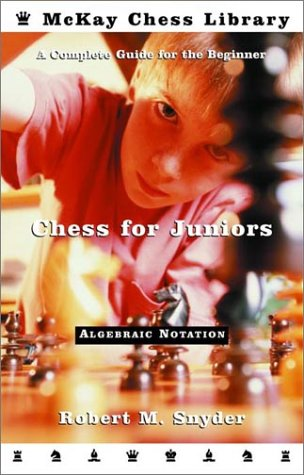Is this a comedy book? This is not a comedy book. Despite its classification under 'Humor & Entertainment', it is in fact a serious educational resource on learning chess. 